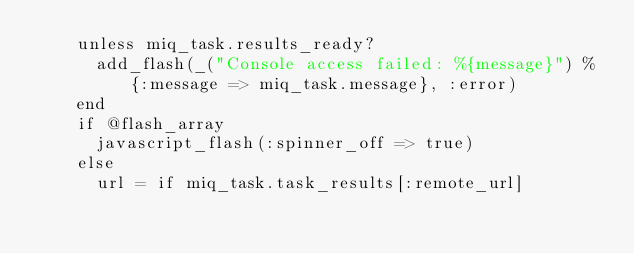Convert code to text. <code><loc_0><loc_0><loc_500><loc_500><_Ruby_>    unless miq_task.results_ready?
      add_flash(_("Console access failed: %{message}") % {:message => miq_task.message}, :error)
    end
    if @flash_array
      javascript_flash(:spinner_off => true)
    else
      url = if miq_task.task_results[:remote_url]</code> 